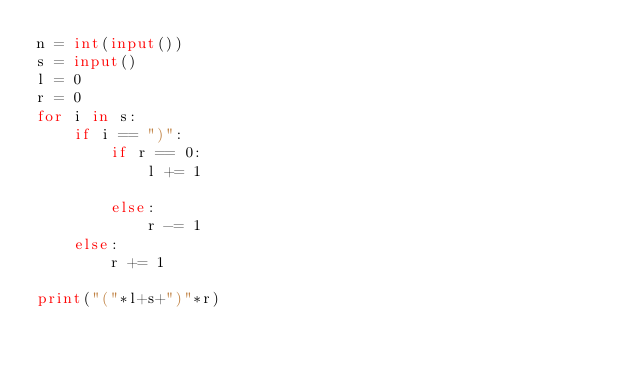<code> <loc_0><loc_0><loc_500><loc_500><_Python_>n = int(input())
s = input()
l = 0
r = 0
for i in s:
    if i == ")":
        if r == 0:
            l += 1
            
        else:
            r -= 1
    else:
        r += 1

print("("*l+s+")"*r)
</code> 